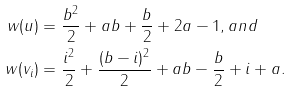Convert formula to latex. <formula><loc_0><loc_0><loc_500><loc_500>w ( u ) & = \frac { b ^ { 2 } } 2 + a b + \frac { b } { 2 } + 2 a - 1 , a n d \\ w ( v _ { i } ) & = \frac { i ^ { 2 } } 2 + \frac { ( b - i ) ^ { 2 } } 2 + a b - \frac { b } { 2 } + i + a .</formula> 